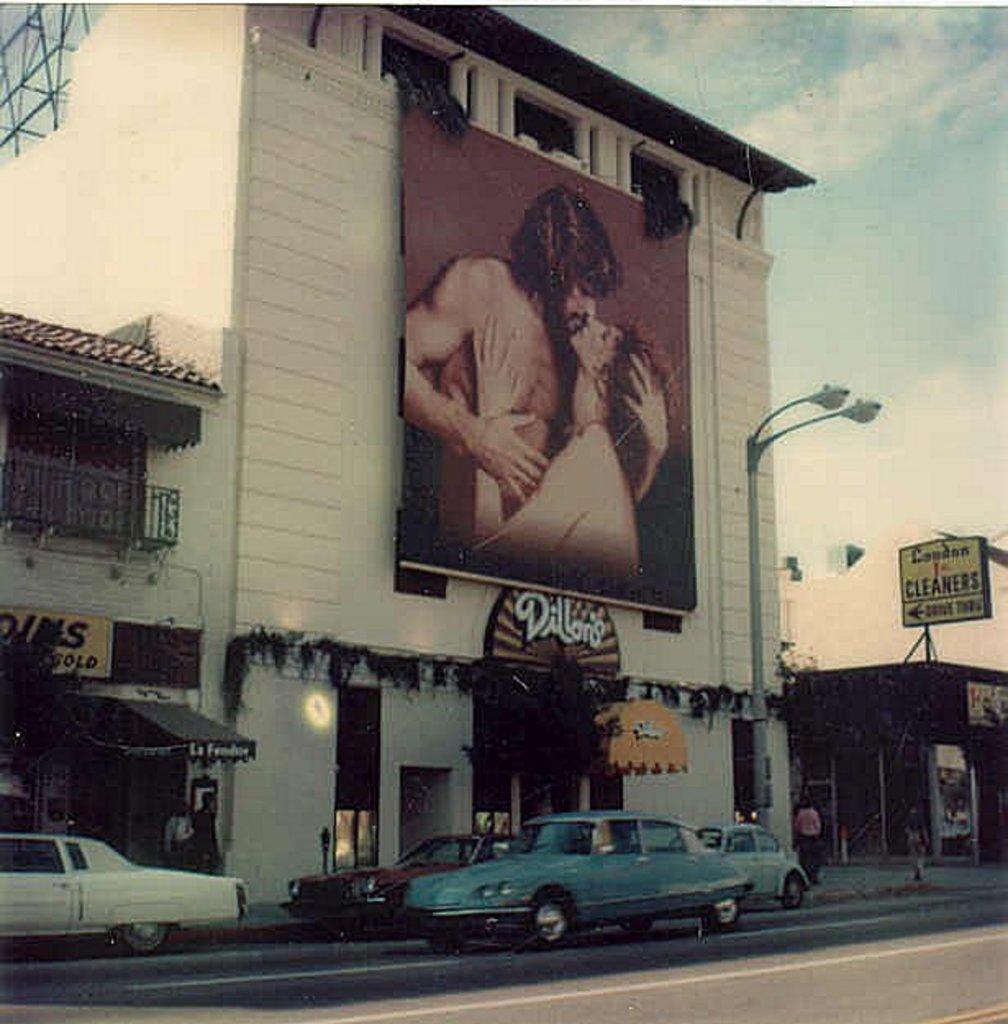How would you summarize this image in a sentence or two? In the image we can see there are many vehicles on the road, this is a building, light, light pole and poster. We can even see there are people on the footpath and a cloudy sky. This is a fence. 